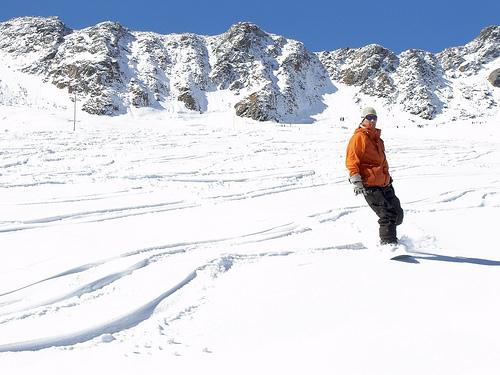Briefly describe the central theme of the image and what the main subject is doing. The central theme is snowboarding; a man clad in vibrant clothing is making his way down a snow-covered mountain slope. Write a concise description of the main subject and their surroundings in the image. A snowboarder wearing sunglasses and an orange jacket is navigating his way down a beautiful, snow-covered mountain slope. Can you describe the attire of the main subject in the image and the environment they are in? The snowboarder is wearing an orange snow jacket, black ski pants, and sunglasses, as he goes down a snowy mountain slope. Describe the primary object in the image and their surroundings. The primary object is a snowboarder dressed in an orange jacket, going down a snowy mountain slope with snow-covered mountains in the background. Describe how the person is dressed and what they're doing in the image. A man sporting a white beanie, sunglasses, and an orange jacket is snowboarding down a snow-filled mountain slope. Provide a brief description of the primary scene in the image. A snowboarder is going down a mountain slope filled with snow, wearing sunglasses and surrounded by snow-covered mountains. What is the main action being performed in the image? A snowboarder, wearing an orange jacket and sunglasses, is gliding down a snowy mountain slope. Tell me the key elements of the image and their interaction. A snowboarder in a vibrant jacket is gliding down a snow-covered mountain, leaving tracks behind him. What is the primary focus of the photo and what is happening in the scene? The main focus is a snowboarder in an orange jacket maneuvering down the snowy slopes of a picturesque mountain. Mention the main activity happening in the picture along with the person involved. A man is snowboarding down a snowy slope while wearing an orange jacket and a white beanie. 